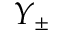Convert formula to latex. <formula><loc_0><loc_0><loc_500><loc_500>Y _ { \pm }</formula> 